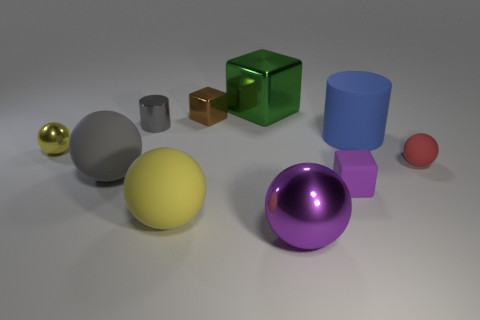There is a rubber ball that is the same color as the metal cylinder; what is its size?
Offer a very short reply. Large. There is a metallic ball that is in front of the yellow object that is in front of the red matte object; are there any red rubber balls that are in front of it?
Make the answer very short. No. What number of cylinders are tiny brown metallic things or gray things?
Ensure brevity in your answer.  1. There is a green object; does it have the same shape as the tiny metallic thing behind the metallic cylinder?
Your answer should be compact. Yes. Is the number of gray rubber spheres that are in front of the purple ball less than the number of tiny blue spheres?
Your response must be concise. No. Are there any spheres to the left of the large purple metal thing?
Your answer should be very brief. Yes. Are there any tiny matte objects of the same shape as the large purple metal object?
Make the answer very short. Yes. What shape is the blue object that is the same size as the green thing?
Keep it short and to the point. Cylinder. How many things are metal balls that are to the left of the small gray metallic cylinder or small yellow rubber things?
Offer a terse response. 1. Does the metallic cylinder have the same color as the rubber cylinder?
Provide a short and direct response. No. 